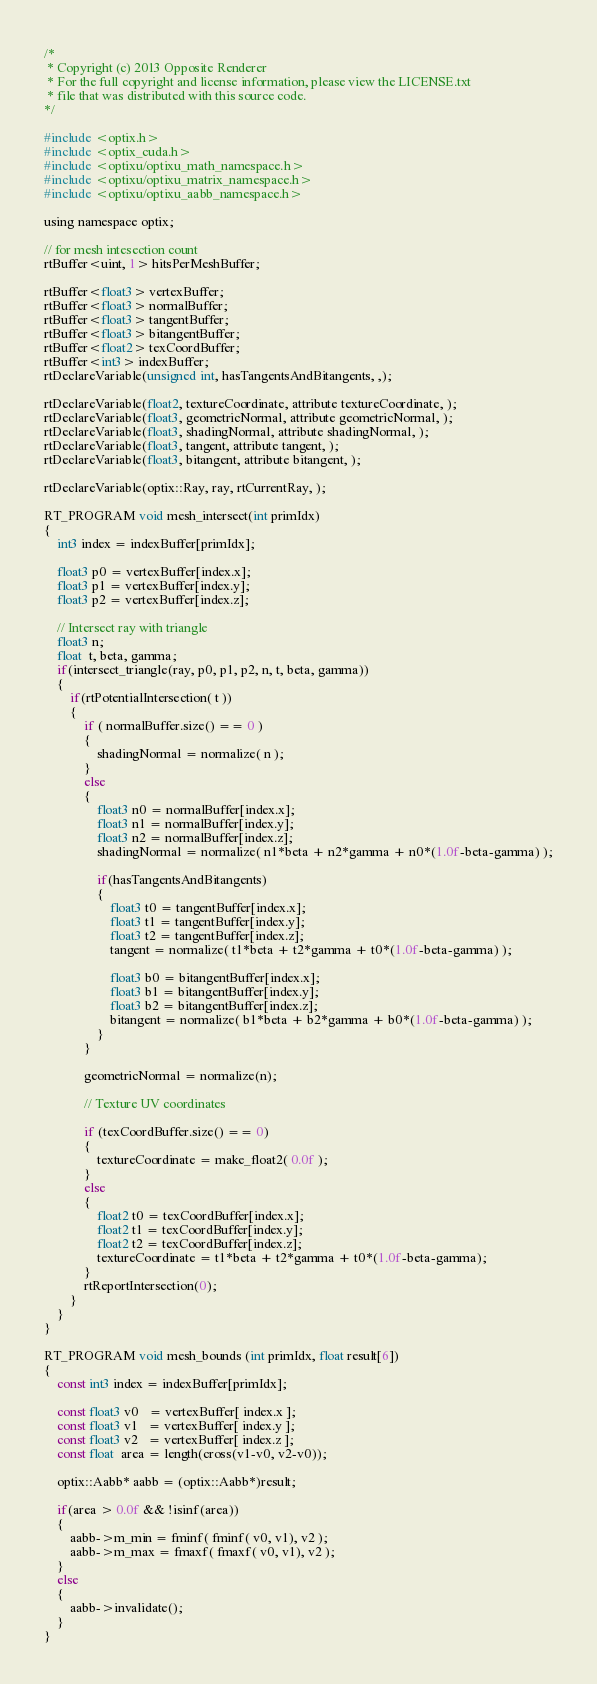<code> <loc_0><loc_0><loc_500><loc_500><_Cuda_>/* 
 * Copyright (c) 2013 Opposite Renderer
 * For the full copyright and license information, please view the LICENSE.txt
 * file that was distributed with this source code.
*/

#include <optix.h>
#include <optix_cuda.h>
#include <optixu/optixu_math_namespace.h>
#include <optixu/optixu_matrix_namespace.h>
#include <optixu/optixu_aabb_namespace.h>

using namespace optix;

// for mesh intesection count
rtBuffer<uint, 1> hitsPerMeshBuffer;

rtBuffer<float3> vertexBuffer;     
rtBuffer<float3> normalBuffer;
rtBuffer<float3> tangentBuffer;
rtBuffer<float3> bitangentBuffer;
rtBuffer<float2> texCoordBuffer;
rtBuffer<int3> indexBuffer; 
rtDeclareVariable(unsigned int, hasTangentsAndBitangents, ,);

rtDeclareVariable(float2, textureCoordinate, attribute textureCoordinate, ); 
rtDeclareVariable(float3, geometricNormal, attribute geometricNormal, ); 
rtDeclareVariable(float3, shadingNormal, attribute shadingNormal, ); 
rtDeclareVariable(float3, tangent, attribute tangent, ); 
rtDeclareVariable(float3, bitangent, attribute bitangent, ); 

rtDeclareVariable(optix::Ray, ray, rtCurrentRay, );

RT_PROGRAM void mesh_intersect(int primIdx)
{
    int3 index = indexBuffer[primIdx];

    float3 p0 = vertexBuffer[index.x];
    float3 p1 = vertexBuffer[index.y];
    float3 p2 = vertexBuffer[index.z];

    // Intersect ray with triangle
    float3 n;
    float  t, beta, gamma;
    if(intersect_triangle(ray, p0, p1, p2, n, t, beta, gamma))
    {
        if(rtPotentialIntersection( t ))
        {
            if ( normalBuffer.size() == 0 )
            {
                shadingNormal = normalize( n );
            }
            else
            {
                float3 n0 = normalBuffer[index.x];
                float3 n1 = normalBuffer[index.y];
                float3 n2 = normalBuffer[index.z];
                shadingNormal = normalize( n1*beta + n2*gamma + n0*(1.0f-beta-gamma) );

                if(hasTangentsAndBitangents)
                {
                    float3 t0 = tangentBuffer[index.x];
                    float3 t1 = tangentBuffer[index.y];
                    float3 t2 = tangentBuffer[index.z];
                    tangent = normalize( t1*beta + t2*gamma + t0*(1.0f-beta-gamma) );

                    float3 b0 = bitangentBuffer[index.x];
                    float3 b1 = bitangentBuffer[index.y];
                    float3 b2 = bitangentBuffer[index.z];
                    bitangent = normalize( b1*beta + b2*gamma + b0*(1.0f-beta-gamma) );
                }
            }

            geometricNormal = normalize(n);

            // Texture UV coordinates

            if (texCoordBuffer.size() == 0)
            {
                textureCoordinate = make_float2( 0.0f );
            }
            else
            {
                float2 t0 = texCoordBuffer[index.x];
                float2 t1 = texCoordBuffer[index.y];
                float2 t2 = texCoordBuffer[index.z];
                textureCoordinate = t1*beta + t2*gamma + t0*(1.0f-beta-gamma);
            }
            rtReportIntersection(0);
        }
    }
}

RT_PROGRAM void mesh_bounds (int primIdx, float result[6])
{  
    const int3 index = indexBuffer[primIdx];

    const float3 v0   = vertexBuffer[ index.x ];
    const float3 v1   = vertexBuffer[ index.y ];
    const float3 v2   = vertexBuffer[ index.z ];
    const float  area = length(cross(v1-v0, v2-v0));

    optix::Aabb* aabb = (optix::Aabb*)result;

    if(area > 0.0f && !isinf(area))
    {
        aabb->m_min = fminf( fminf( v0, v1), v2 );
        aabb->m_max = fmaxf( fmaxf( v0, v1), v2 );
    }
    else 
    {
        aabb->invalidate();
    }
}
</code> 